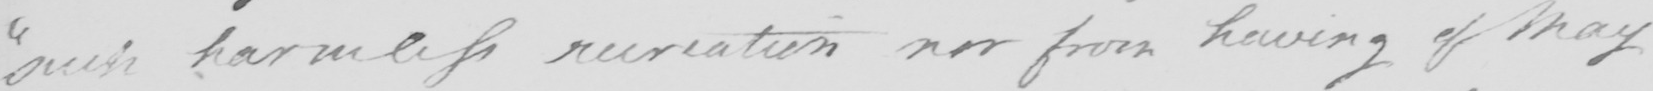What is written in this line of handwriting? " such harmless recreation nor from having of May 